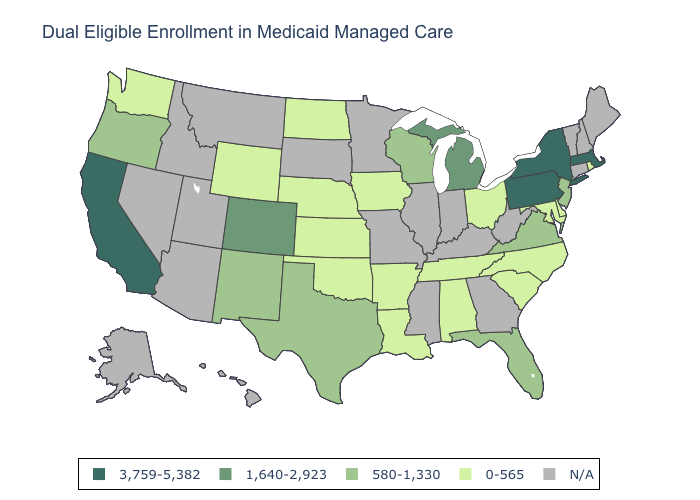What is the highest value in the South ?
Be succinct. 580-1,330. What is the value of Ohio?
Answer briefly. 0-565. Does North Dakota have the lowest value in the USA?
Short answer required. Yes. What is the lowest value in the South?
Write a very short answer. 0-565. Does the first symbol in the legend represent the smallest category?
Keep it brief. No. Among the states that border Connecticut , which have the highest value?
Answer briefly. Massachusetts, New York. Does the first symbol in the legend represent the smallest category?
Answer briefly. No. What is the value of Alabama?
Short answer required. 0-565. Name the states that have a value in the range 0-565?
Write a very short answer. Alabama, Arkansas, Delaware, Iowa, Kansas, Louisiana, Maryland, Nebraska, North Carolina, North Dakota, Ohio, Oklahoma, Rhode Island, South Carolina, Tennessee, Washington, Wyoming. Among the states that border Wisconsin , which have the highest value?
Quick response, please. Michigan. Name the states that have a value in the range 580-1,330?
Give a very brief answer. Florida, New Jersey, New Mexico, Oregon, Texas, Virginia, Wisconsin. Does the first symbol in the legend represent the smallest category?
Be succinct. No. What is the value of Ohio?
Be succinct. 0-565. Name the states that have a value in the range 1,640-2,923?
Be succinct. Colorado, Michigan. 